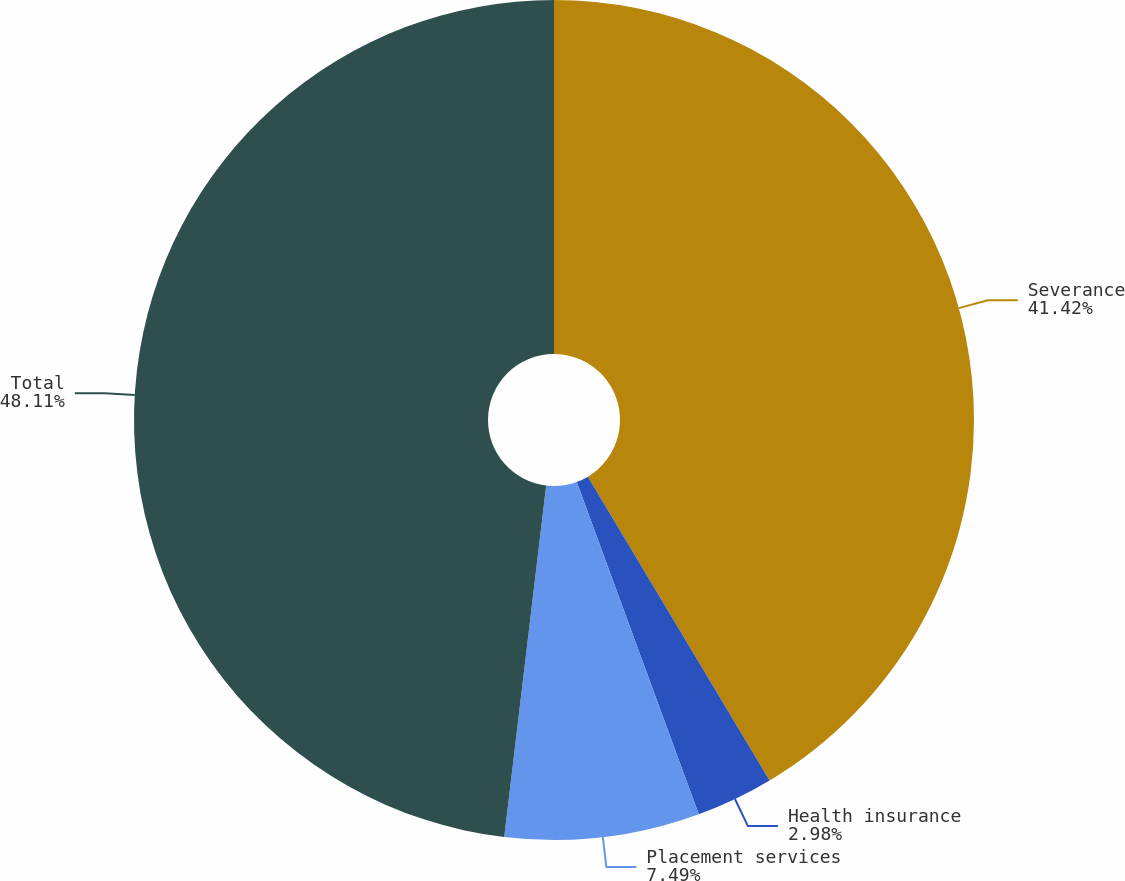<chart> <loc_0><loc_0><loc_500><loc_500><pie_chart><fcel>Severance<fcel>Health insurance<fcel>Placement services<fcel>Total<nl><fcel>41.42%<fcel>2.98%<fcel>7.49%<fcel>48.11%<nl></chart> 